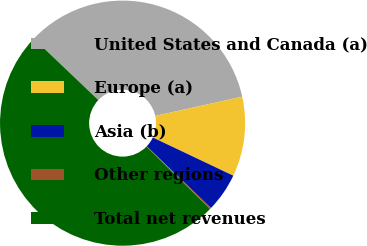Convert chart. <chart><loc_0><loc_0><loc_500><loc_500><pie_chart><fcel>United States and Canada (a)<fcel>Europe (a)<fcel>Asia (b)<fcel>Other regions<fcel>Total net revenues<nl><fcel>34.43%<fcel>10.52%<fcel>5.13%<fcel>0.17%<fcel>49.76%<nl></chart> 